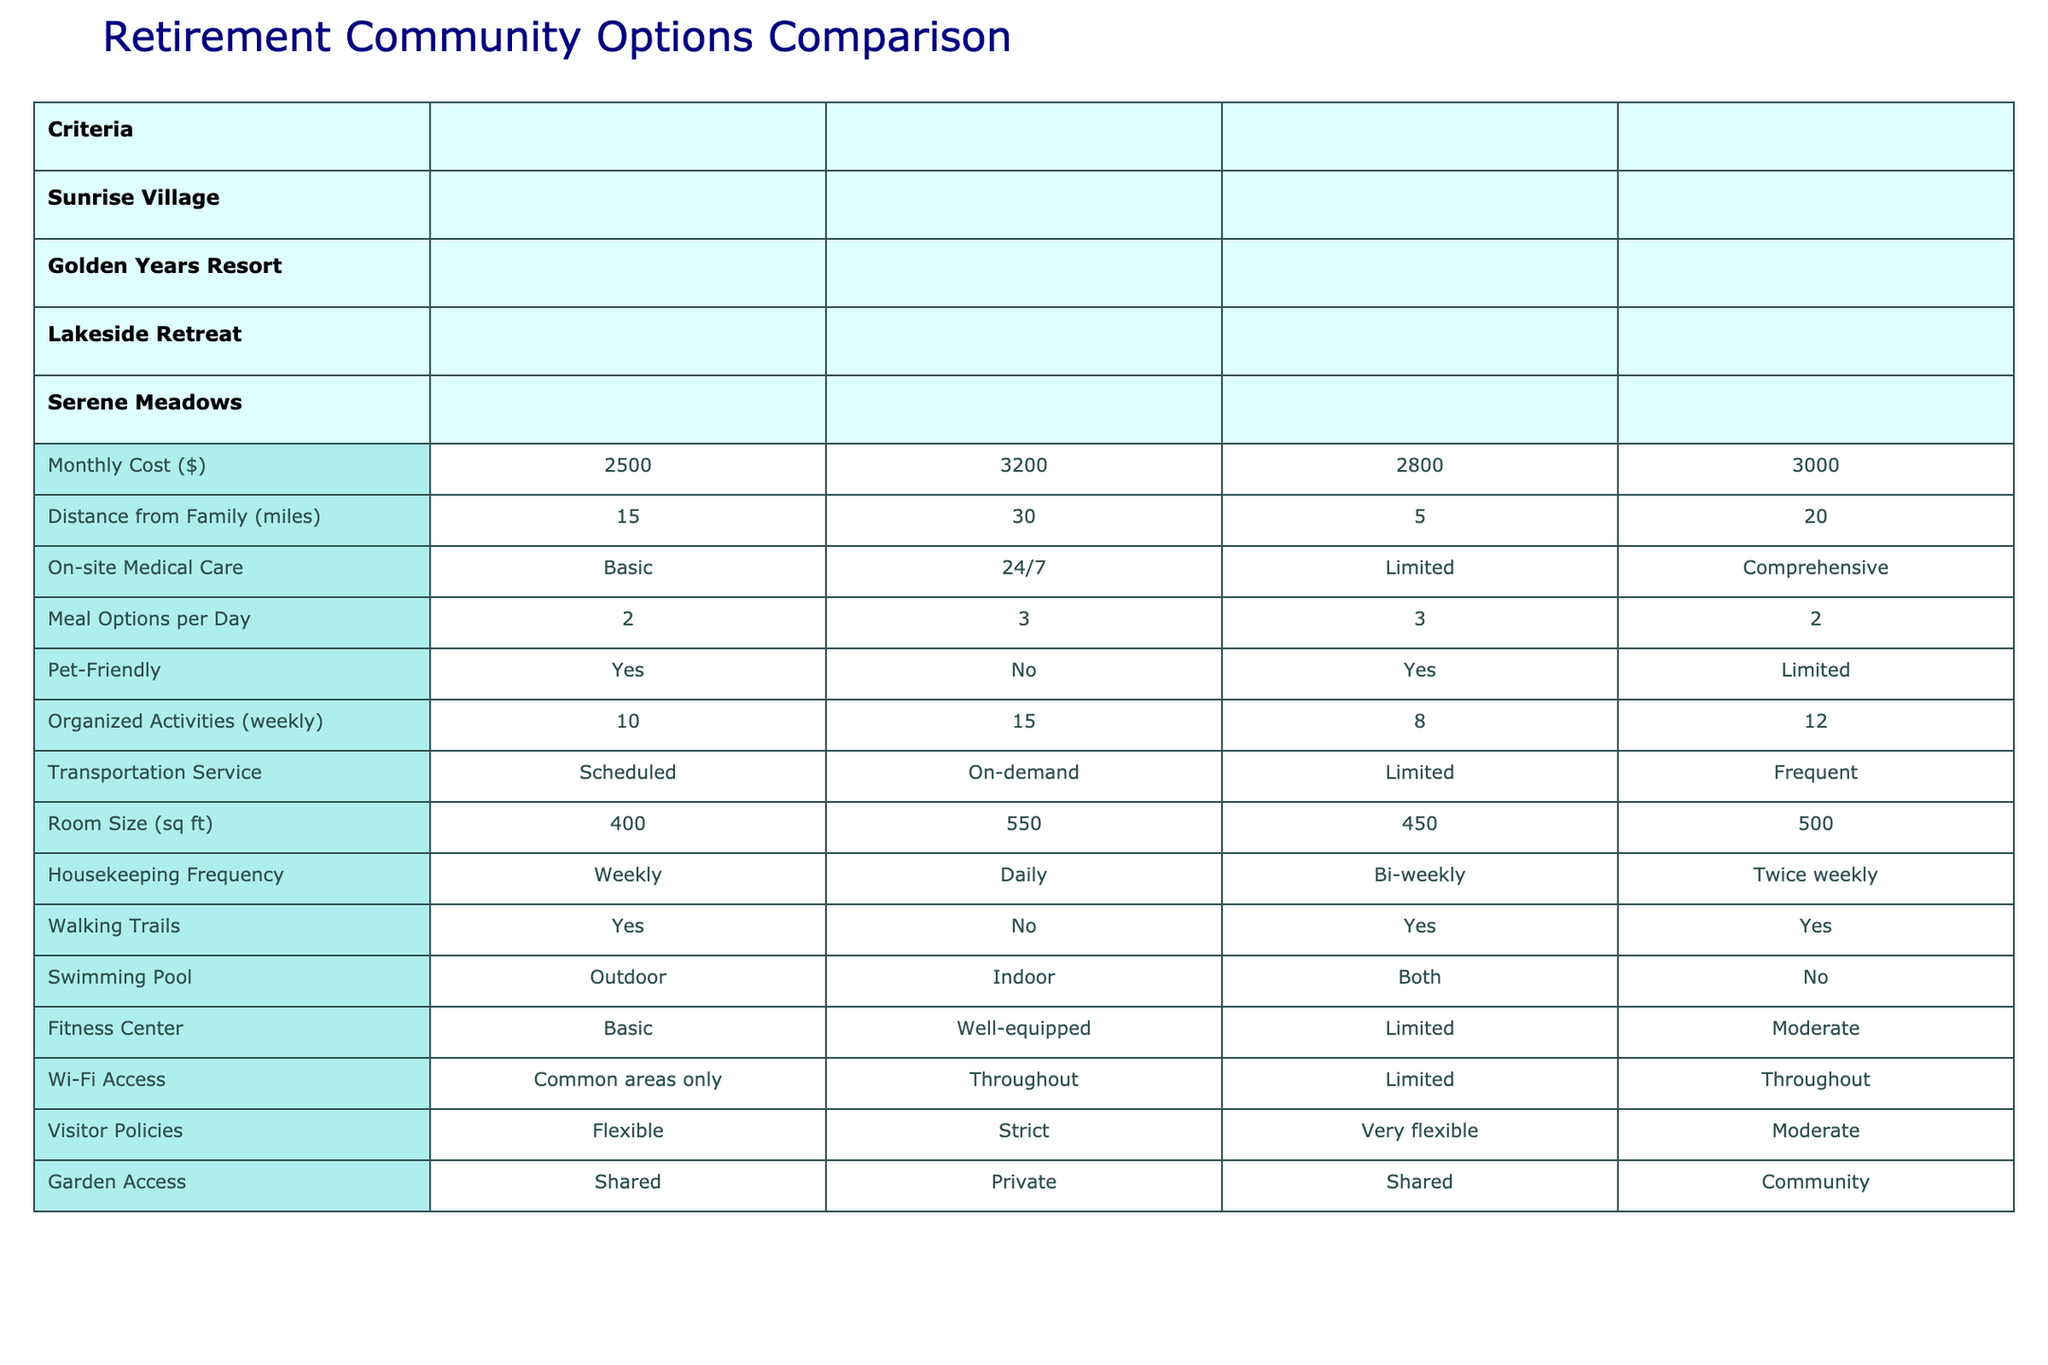What is the monthly cost of Lakeside Retreat? The table shows that for Lakeside Retreat, the Monthly Cost is listed as 2800.
Answer: 2800 Which retirement community offers 24/7 on-site medical care? According to the table, Golden Years Resort provides 24/7 on-site medical care.
Answer: Golden Years Resort What is the distance from family for the community with the highest organized activities per week? The community with the highest organized activities (15 per week) is Golden Years Resort, and its distance from family is 30 miles.
Answer: 30 miles How many meal options per day does Serene Meadows provide? The table indicates that Serene Meadows offers 2 meal options per day.
Answer: 2 Is Lakeside Retreat a pet-friendly community? The table indicates that Lakeside Retreat is indeed pet-friendly as it states "Yes" under Pet-Friendly.
Answer: Yes What is the average monthly cost of the retirement communities listed? The monthly costs are 2500, 3200, 2800, and 3000. Adding these gives 2500 + 3200 + 2800 + 3000 = 11500. Dividing by 4 (the number of communities) gives an average of 11500 / 4 = 2875.
Answer: 2875 Which community has the largest room size and what is that size? From the table, Golden Years Resort has the largest room size at 550 sq ft.
Answer: 550 sq ft How many organized activities does a community that offers frequent transportation service provide? Serene Meadows is the community that provides frequent transportation service, and it offers 12 organized activities per week.
Answer: 12 Is there Wi-Fi access throughout the Golden Years Resort? Upon checking the table, Golden Years Resort does provide Wi-Fi access throughout the facility.
Answer: Yes Which community offers limited pet-friendliness and how does it rank in swimming pool options? Serene Meadows offers limited pet-friendliness and has no swimming pool as per the table.
Answer: Limited pet-friendly, No swimming pool 